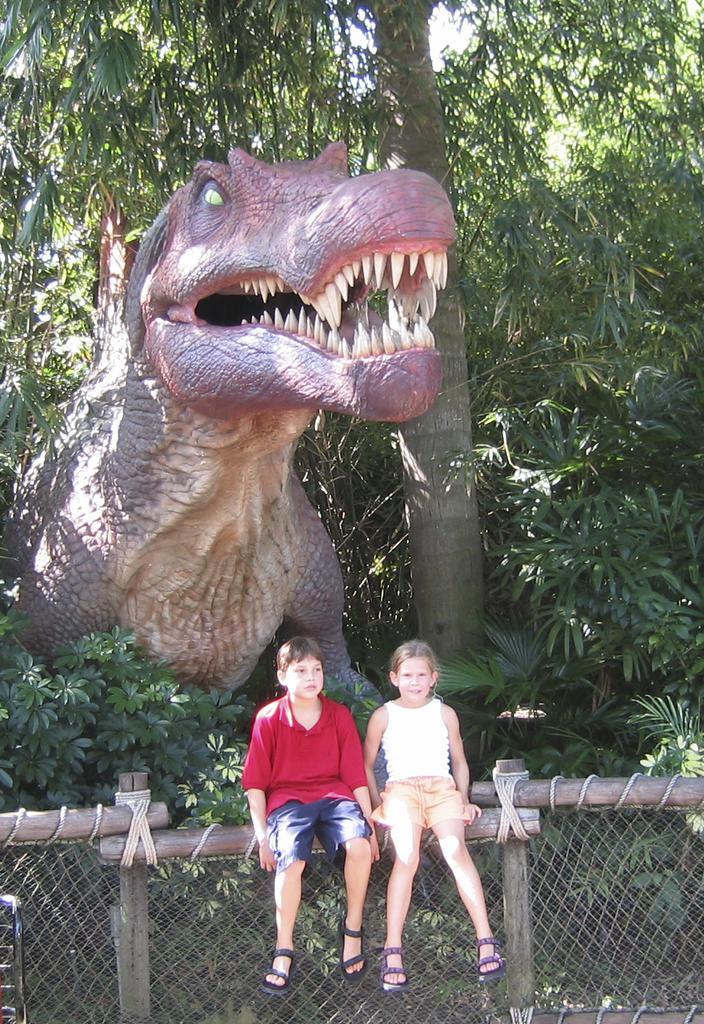Could you give a brief overview of what you see in this image? To the bottom of the image there are few wooden poles with mesh. In the middle of the pole there is a boy with red t-shirt and a girl is sitting on it. Behind them there is a dragon statue and also there are many trees. 